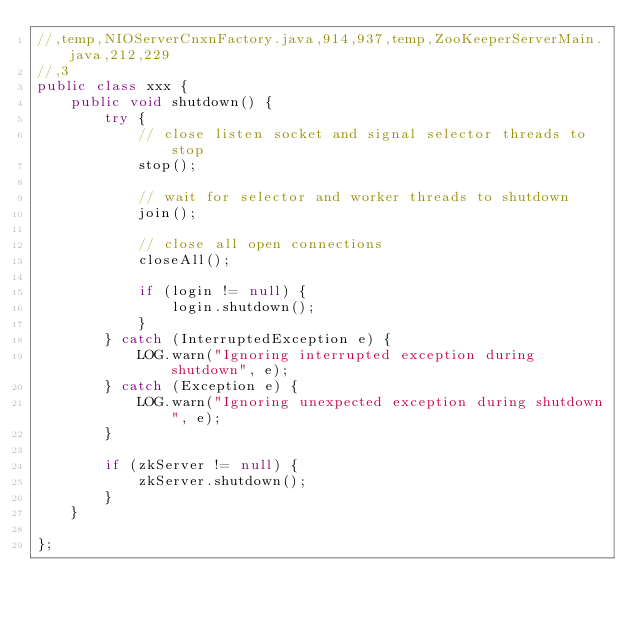<code> <loc_0><loc_0><loc_500><loc_500><_Java_>//,temp,NIOServerCnxnFactory.java,914,937,temp,ZooKeeperServerMain.java,212,229
//,3
public class xxx {
    public void shutdown() {
        try {
            // close listen socket and signal selector threads to stop
            stop();

            // wait for selector and worker threads to shutdown
            join();

            // close all open connections
            closeAll();

            if (login != null) {
                login.shutdown();
            }
        } catch (InterruptedException e) {
            LOG.warn("Ignoring interrupted exception during shutdown", e);
        } catch (Exception e) {
            LOG.warn("Ignoring unexpected exception during shutdown", e);
        }

        if (zkServer != null) {
            zkServer.shutdown();
        }
    }

};</code> 